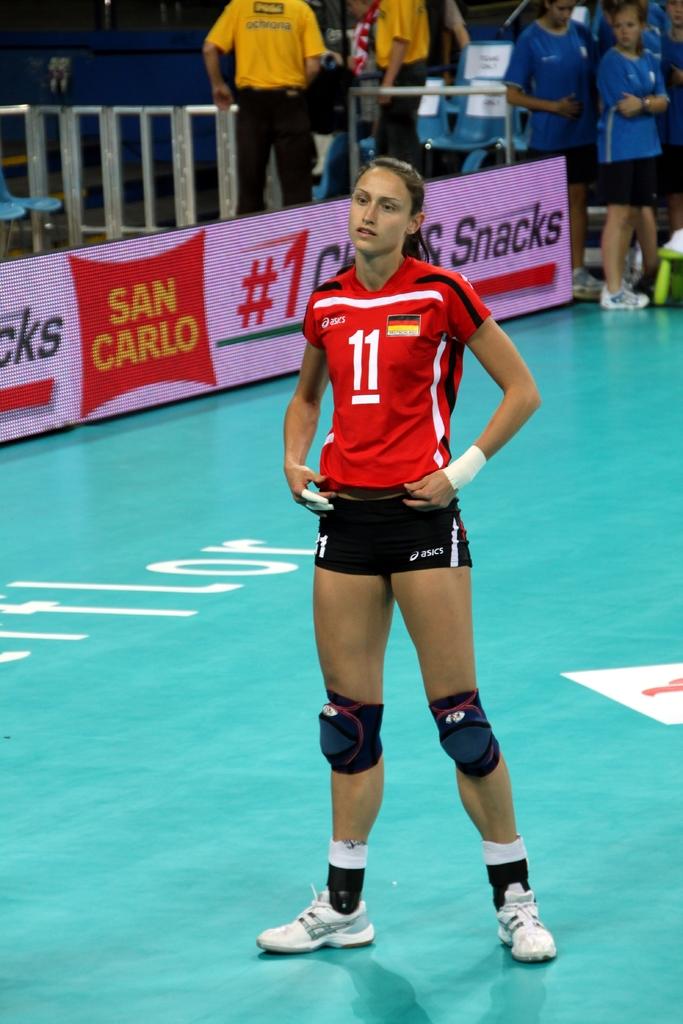What is the number on the girls jersey?
Your response must be concise. 11. What brand name is behind her in yellow letters?
Offer a very short reply. San carlo. 